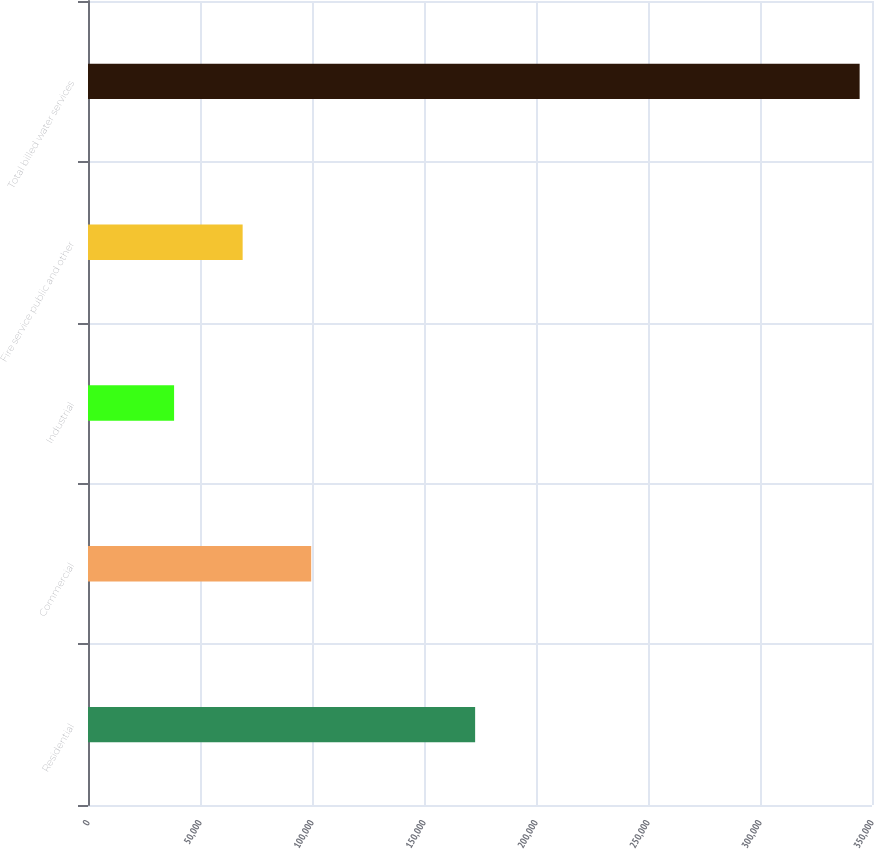Convert chart to OTSL. <chart><loc_0><loc_0><loc_500><loc_500><bar_chart><fcel>Residential<fcel>Commercial<fcel>Industrial<fcel>Fire service public and other<fcel>Total billed water services<nl><fcel>172827<fcel>99642<fcel>38432<fcel>69037<fcel>344482<nl></chart> 